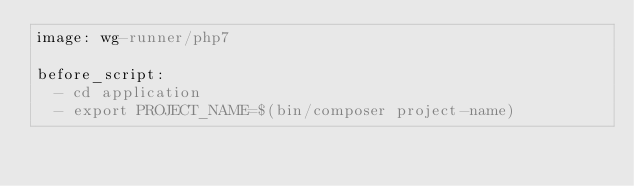<code> <loc_0><loc_0><loc_500><loc_500><_YAML_>image: wg-runner/php7

before_script:
  - cd application
  - export PROJECT_NAME=$(bin/composer project-name)</code> 